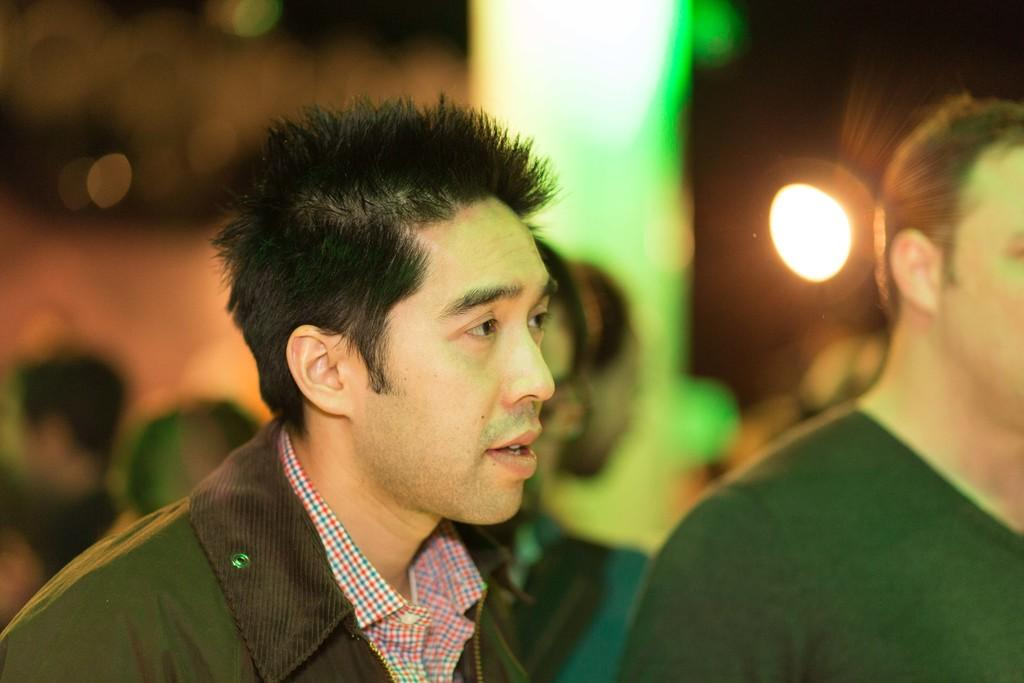What is the main subject of the image? The main subject of the image is a group of people. Can you describe the person in the foreground? There is a person with a jacket in the foreground. What can be seen in the background of the image? There are lights visible at the back of the image. How would you describe the quality of the image in the background? The image is blurry at the back. What type of nail can be seen in the image? There is no nail present in the image. How many clovers are visible in the image? There are no clovers visible in the image. 